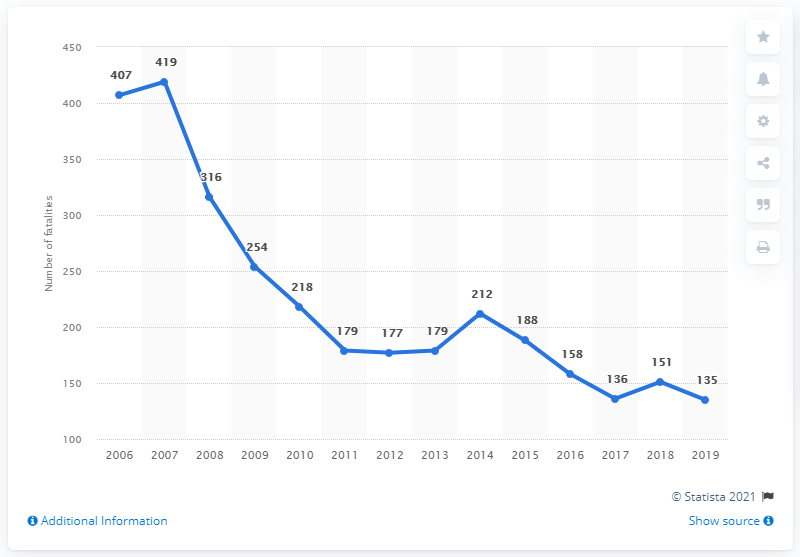Highlight a few significant elements in this photo. During the period of 2006 to 2019, there were a total of 419 road fatalities in Latvia. In 2019, Latvia experienced 135 road traffic fatalities. 